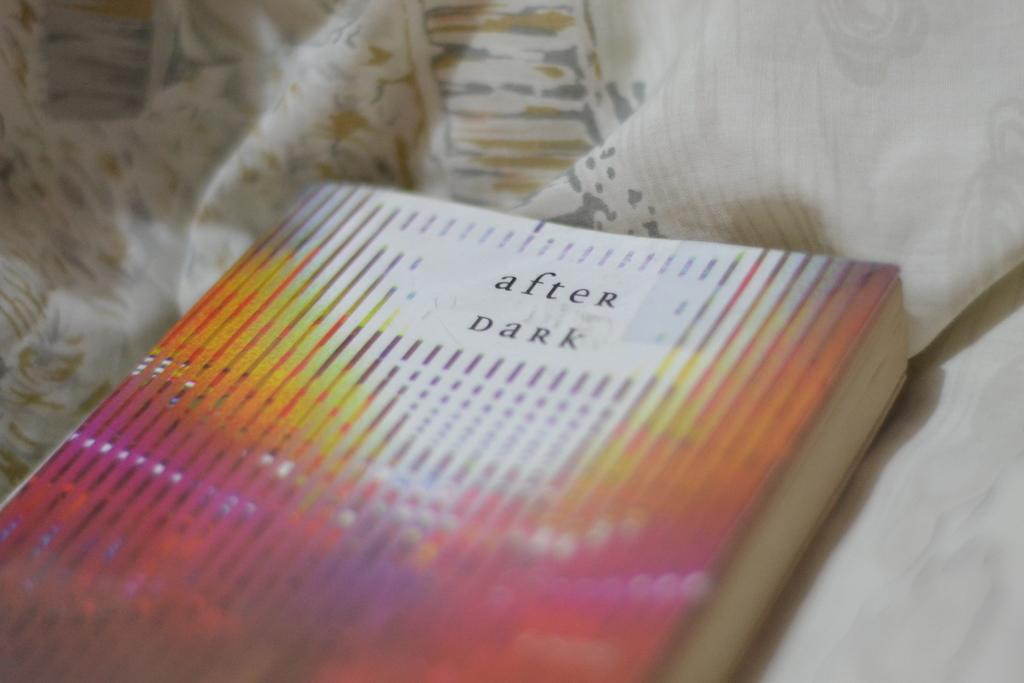<image>
Provide a brief description of the given image. Paperback After Dark book is set in pastel material. 